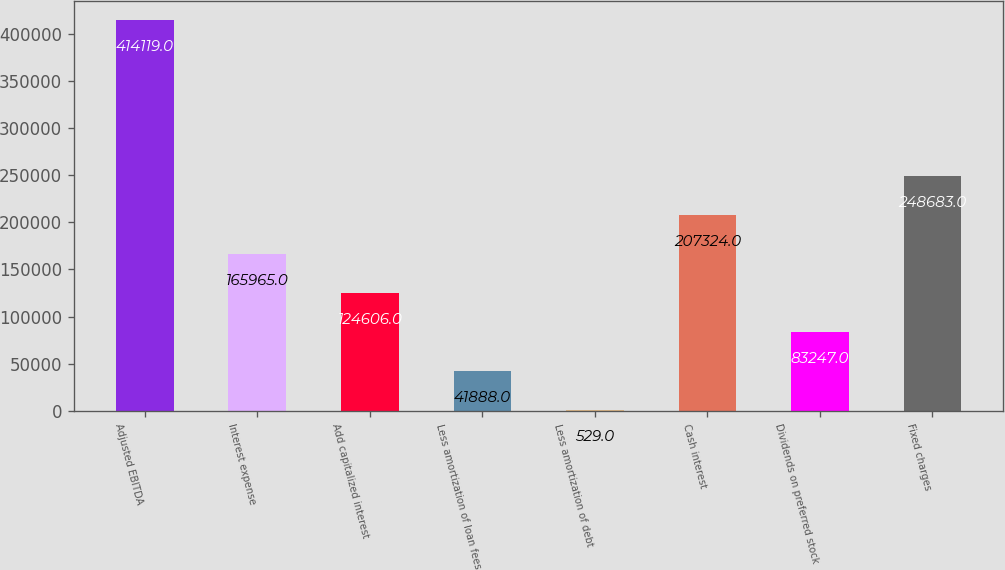Convert chart to OTSL. <chart><loc_0><loc_0><loc_500><loc_500><bar_chart><fcel>Adjusted EBITDA<fcel>Interest expense<fcel>Add capitalized interest<fcel>Less amortization of loan fees<fcel>Less amortization of debt<fcel>Cash interest<fcel>Dividends on preferred stock<fcel>Fixed charges<nl><fcel>414119<fcel>165965<fcel>124606<fcel>41888<fcel>529<fcel>207324<fcel>83247<fcel>248683<nl></chart> 